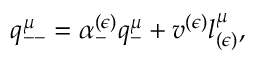Convert formula to latex. <formula><loc_0><loc_0><loc_500><loc_500>q _ { - - } ^ { \mu } = \alpha _ { - } ^ { ( \epsilon ) } q _ { - } ^ { \mu } + v ^ { ( \epsilon ) } l _ { ( \epsilon ) } ^ { \mu } ,</formula> 